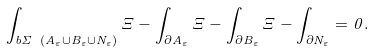<formula> <loc_0><loc_0><loc_500><loc_500>\int _ { b \Sigma \ ( A _ { \varepsilon } \cup B _ { \varepsilon } \cup N _ { \varepsilon } ) } \Xi - \int _ { \partial A _ { \varepsilon } } \Xi - \int _ { \partial B _ { \varepsilon } } \Xi - \int _ { \partial N _ { \varepsilon } } = 0 .</formula> 